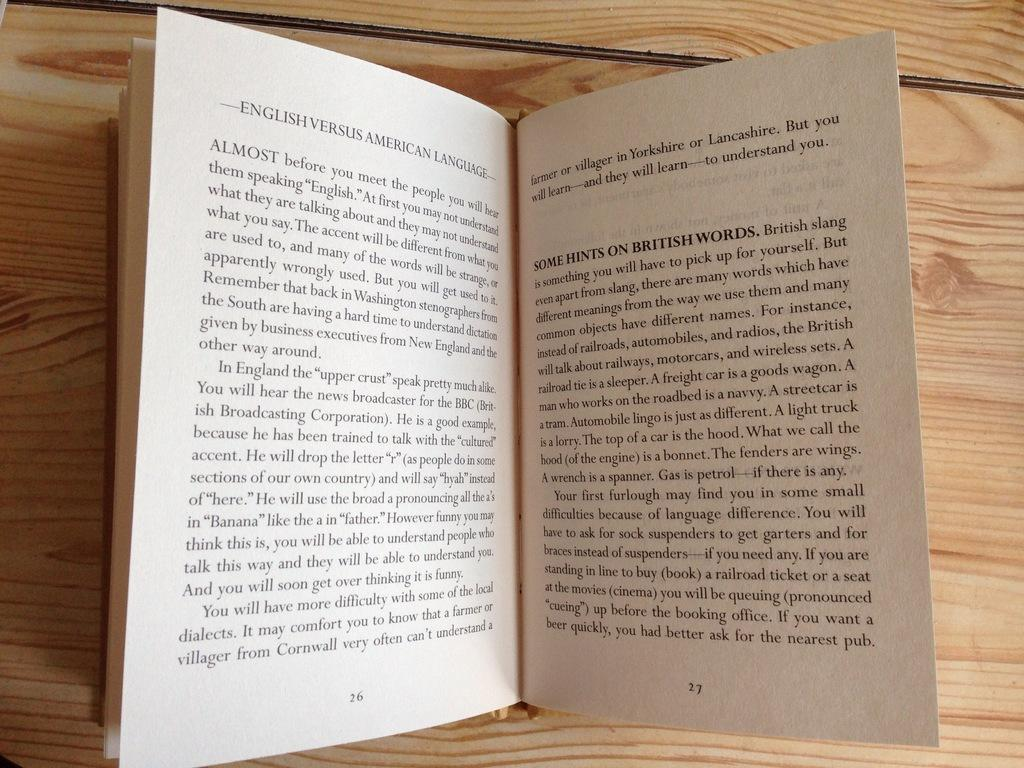<image>
Offer a succinct explanation of the picture presented. Two pages of the book English Versus American Launguage. 